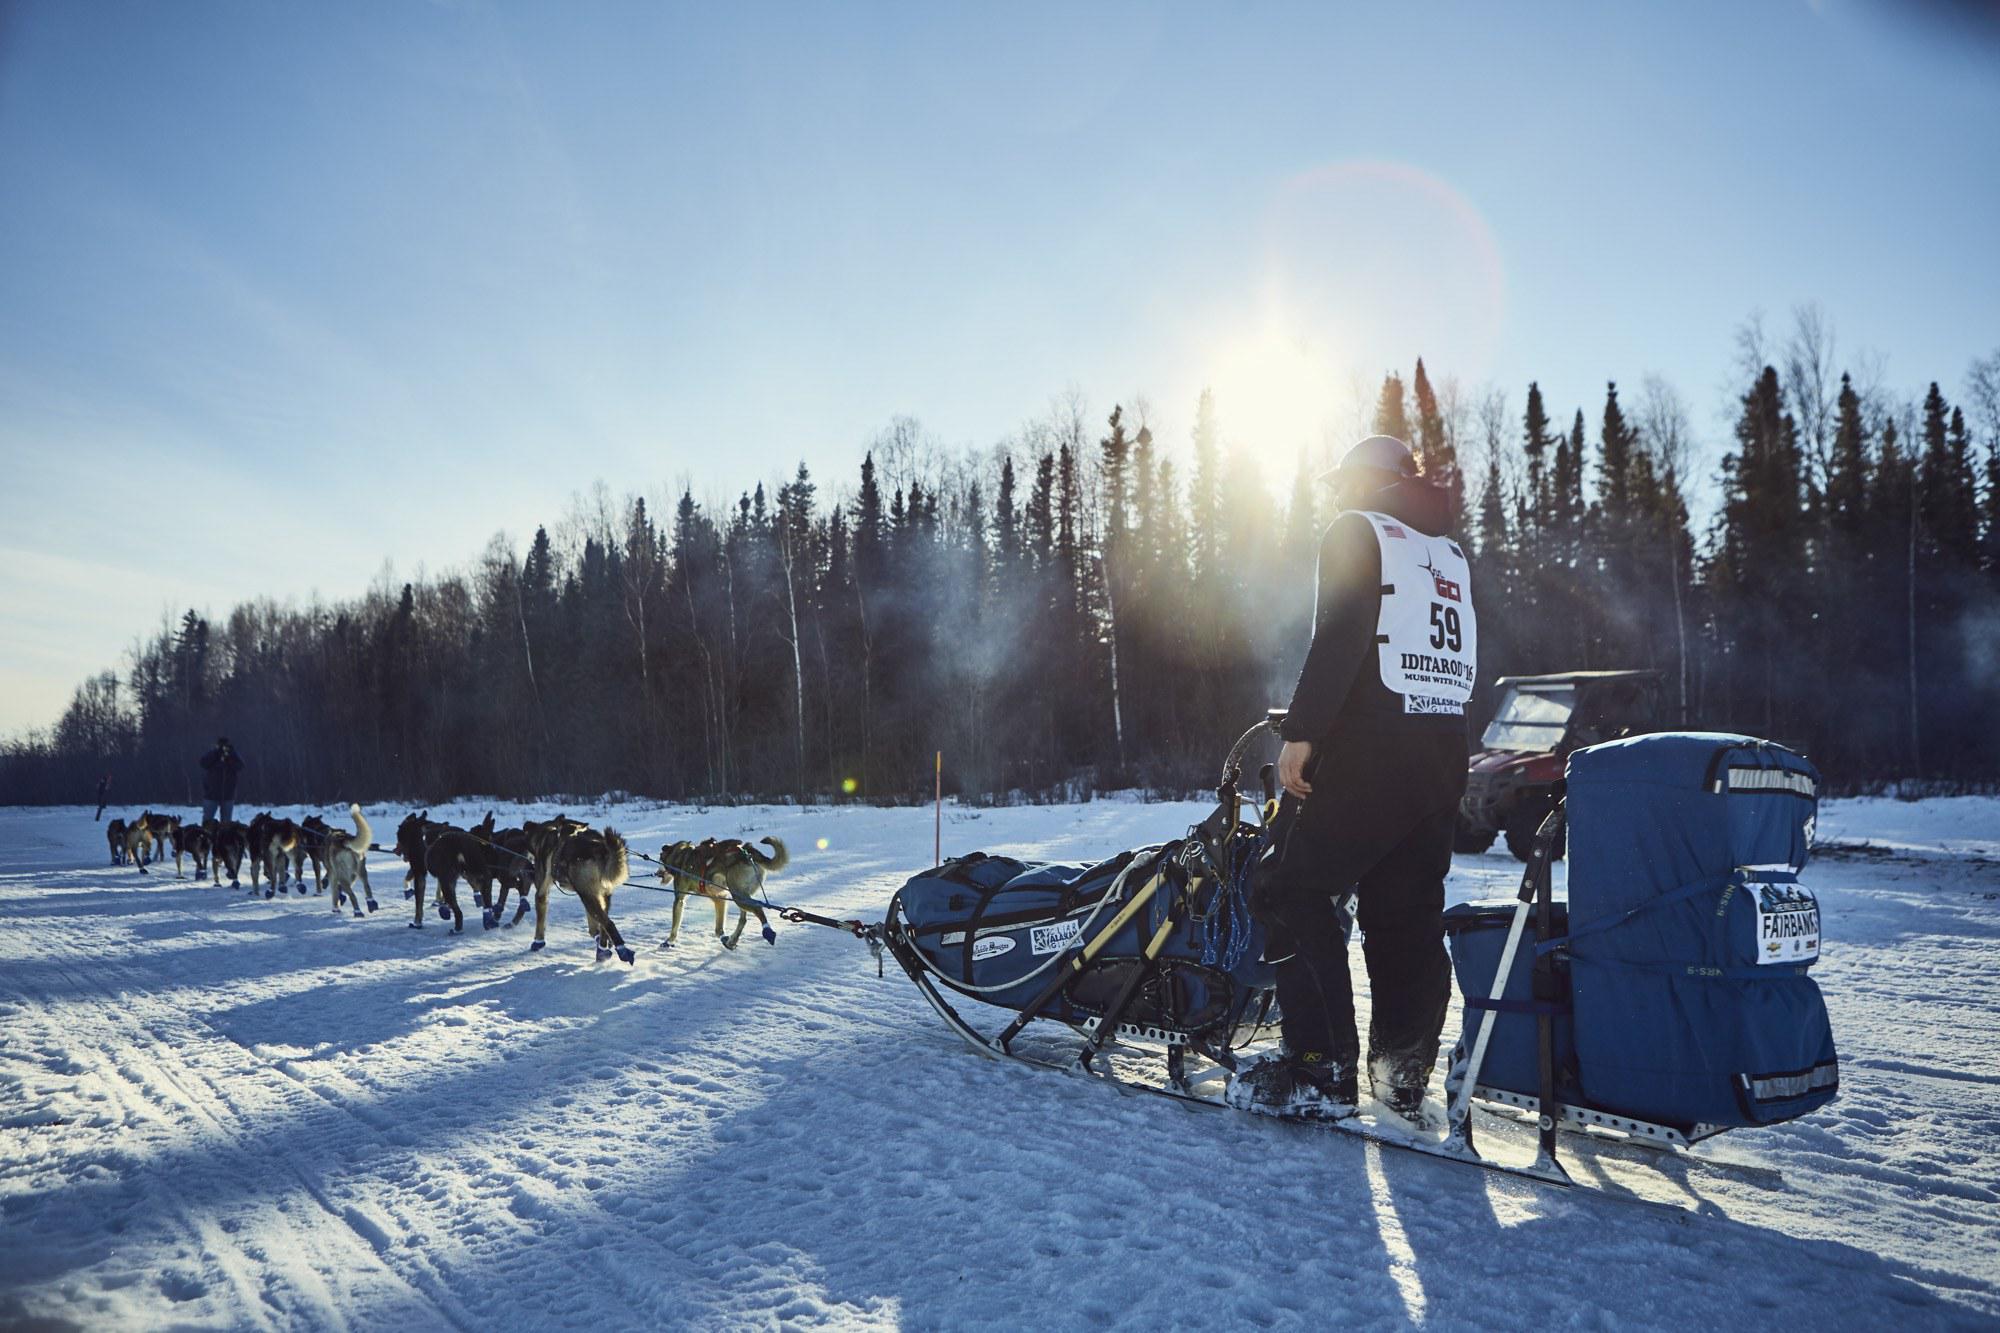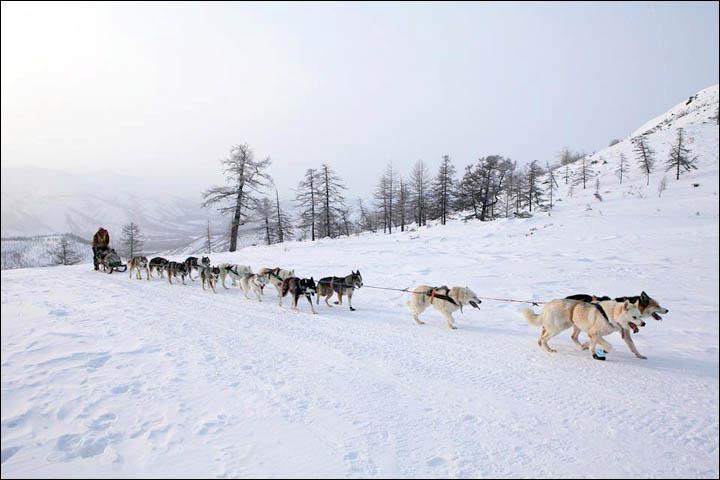The first image is the image on the left, the second image is the image on the right. Evaluate the accuracy of this statement regarding the images: "There are less than three dogs on the snow in one of the images.". Is it true? Answer yes or no. No. The first image is the image on the left, the second image is the image on the right. Considering the images on both sides, is "One image shows no more than two harnessed dogs, which are moving across the snow." valid? Answer yes or no. No. The first image is the image on the left, the second image is the image on the right. Considering the images on both sides, is "The sled dog team on the left heads leftward, and the dog team on the right heads rightward, and each team appears to be moving." valid? Answer yes or no. Yes. The first image is the image on the left, the second image is the image on the right. Evaluate the accuracy of this statement regarding the images: "Less than three dogs are visible in one of the images.". Is it true? Answer yes or no. No. 